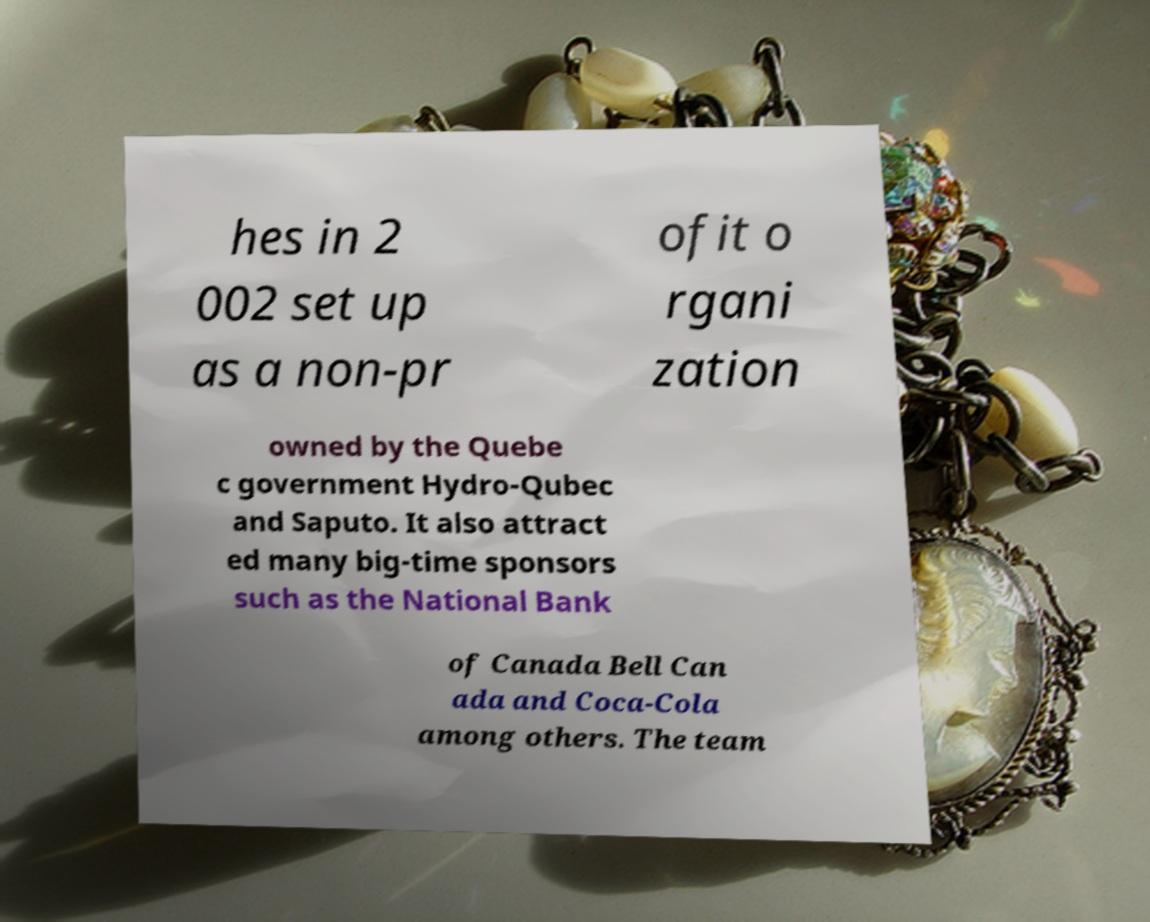Can you accurately transcribe the text from the provided image for me? hes in 2 002 set up as a non-pr ofit o rgani zation owned by the Quebe c government Hydro-Qubec and Saputo. It also attract ed many big-time sponsors such as the National Bank of Canada Bell Can ada and Coca-Cola among others. The team 